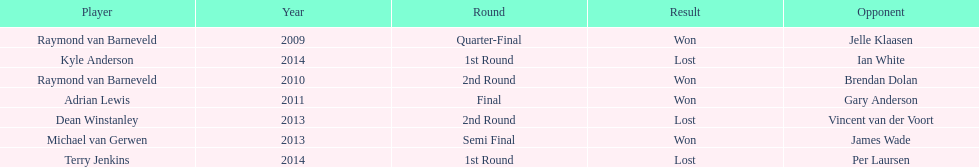Who are the only players listed that played in 2011? Adrian Lewis. Give me the full table as a dictionary. {'header': ['Player', 'Year', 'Round', 'Result', 'Opponent'], 'rows': [['Raymond van Barneveld', '2009', 'Quarter-Final', 'Won', 'Jelle Klaasen'], ['Kyle Anderson', '2014', '1st Round', 'Lost', 'Ian White'], ['Raymond van Barneveld', '2010', '2nd Round', 'Won', 'Brendan Dolan'], ['Adrian Lewis', '2011', 'Final', 'Won', 'Gary Anderson'], ['Dean Winstanley', '2013', '2nd Round', 'Lost', 'Vincent van der Voort'], ['Michael van Gerwen', '2013', 'Semi Final', 'Won', 'James Wade'], ['Terry Jenkins', '2014', '1st Round', 'Lost', 'Per Laursen']]} 